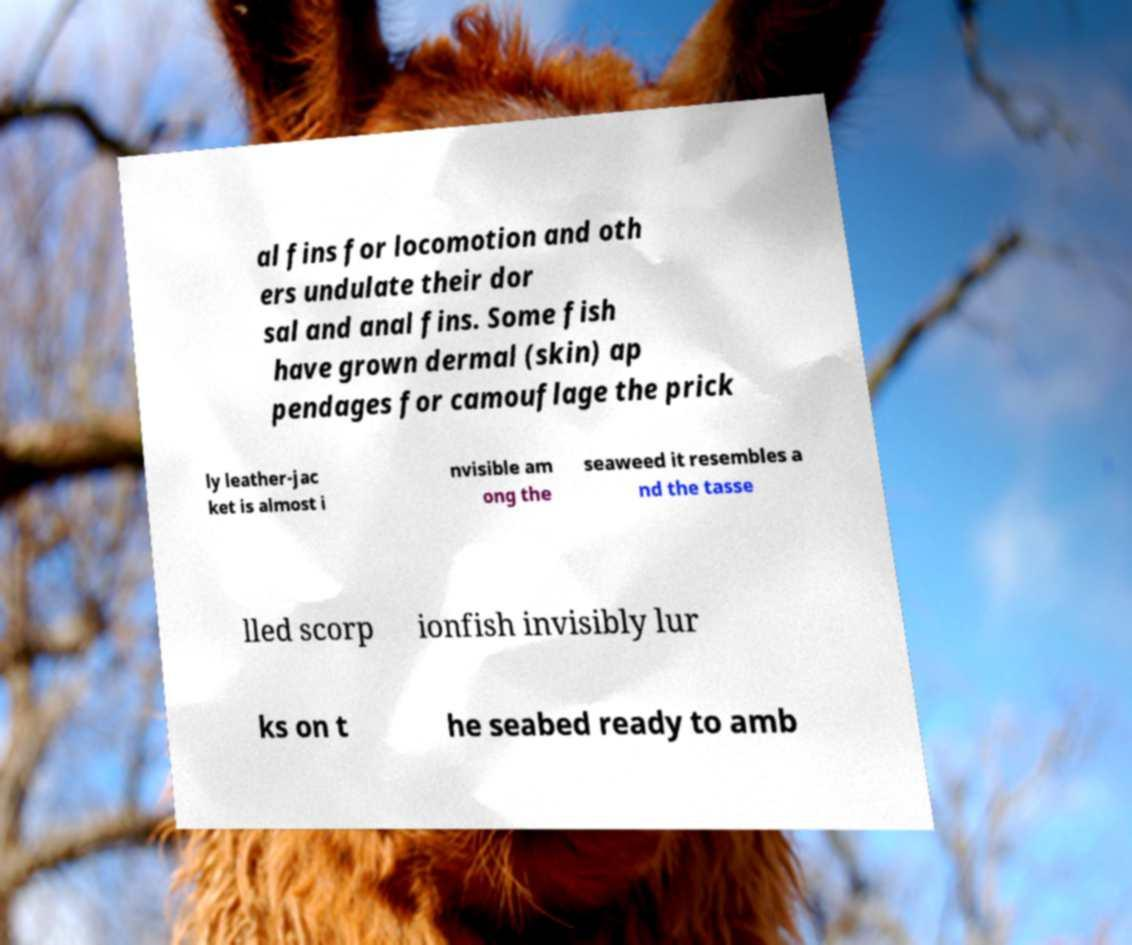There's text embedded in this image that I need extracted. Can you transcribe it verbatim? al fins for locomotion and oth ers undulate their dor sal and anal fins. Some fish have grown dermal (skin) ap pendages for camouflage the prick ly leather-jac ket is almost i nvisible am ong the seaweed it resembles a nd the tasse lled scorp ionfish invisibly lur ks on t he seabed ready to amb 